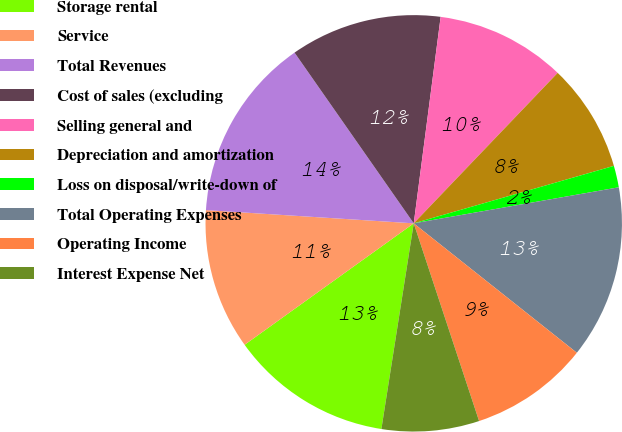Convert chart. <chart><loc_0><loc_0><loc_500><loc_500><pie_chart><fcel>Storage rental<fcel>Service<fcel>Total Revenues<fcel>Cost of sales (excluding<fcel>Selling general and<fcel>Depreciation and amortization<fcel>Loss on disposal/write-down of<fcel>Total Operating Expenses<fcel>Operating Income<fcel>Interest Expense Net<nl><fcel>12.6%<fcel>10.92%<fcel>14.28%<fcel>11.76%<fcel>10.08%<fcel>8.4%<fcel>1.68%<fcel>13.44%<fcel>9.24%<fcel>7.56%<nl></chart> 